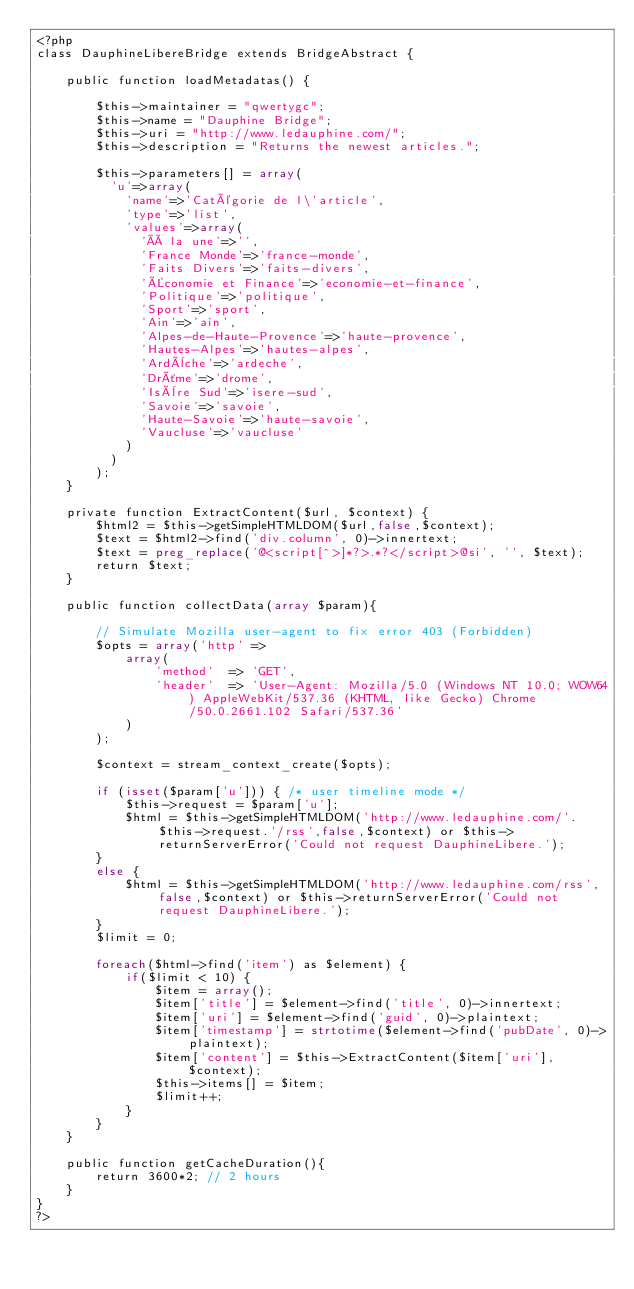<code> <loc_0><loc_0><loc_500><loc_500><_PHP_><?php
class DauphineLibereBridge extends BridgeAbstract {

	public function loadMetadatas() {

		$this->maintainer = "qwertygc";
		$this->name = "Dauphine Bridge";
		$this->uri = "http://www.ledauphine.com/";
		$this->description = "Returns the newest articles.";

        $this->parameters[] = array(
          'u'=>array(
            'name'=>'Catégorie de l\'article',
            'type'=>'list',
            'values'=>array(
              'À la une'=>'',
              'France Monde'=>'france-monde',
              'Faits Divers'=>'faits-divers',
              'Économie et Finance'=>'economie-et-finance',
              'Politique'=>'politique',
              'Sport'=>'sport',
              'Ain'=>'ain',
              'Alpes-de-Haute-Provence'=>'haute-provence',
              'Hautes-Alpes'=>'hautes-alpes',
              'Ardèche'=>'ardeche',
              'Drôme'=>'drome',
              'Isère Sud'=>'isere-sud',
              'Savoie'=>'savoie',
              'Haute-Savoie'=>'haute-savoie',
              'Vaucluse'=>'vaucluse'
            )
          )
        );
	}

	private function ExtractContent($url, $context) {
		$html2 = $this->getSimpleHTMLDOM($url,false,$context);
		$text = $html2->find('div.column', 0)->innertext;
		$text = preg_replace('@<script[^>]*?>.*?</script>@si', '', $text);
		return $text;
	}

	public function collectData(array $param){

		// Simulate Mozilla user-agent to fix error 403 (Forbidden)
		$opts = array('http' =>
			array(
				'method'  => 'GET',
				'header'  => 'User-Agent: Mozilla/5.0 (Windows NT 10.0; WOW64) AppleWebKit/537.36 (KHTML, like Gecko) Chrome/50.0.2661.102 Safari/537.36'
			)
		);

		$context = stream_context_create($opts);

		if (isset($param['u'])) { /* user timeline mode */
			$this->request = $param['u'];
			$html = $this->getSimpleHTMLDOM('http://www.ledauphine.com/'.$this->request.'/rss',false,$context) or $this->returnServerError('Could not request DauphineLibere.');
		}
		else {
			$html = $this->getSimpleHTMLDOM('http://www.ledauphine.com/rss',false,$context) or $this->returnServerError('Could not request DauphineLibere.');
		}
		$limit = 0;

		foreach($html->find('item') as $element) {
			if($limit < 10) {
				$item = array();
				$item['title'] = $element->find('title', 0)->innertext;
				$item['uri'] = $element->find('guid', 0)->plaintext;
				$item['timestamp'] = strtotime($element->find('pubDate', 0)->plaintext);
				$item['content'] = $this->ExtractContent($item['uri'], $context);
				$this->items[] = $item;
				$limit++;
			}
		}
	}

	public function getCacheDuration(){
		return 3600*2; // 2 hours
	}
}
?>
</code> 